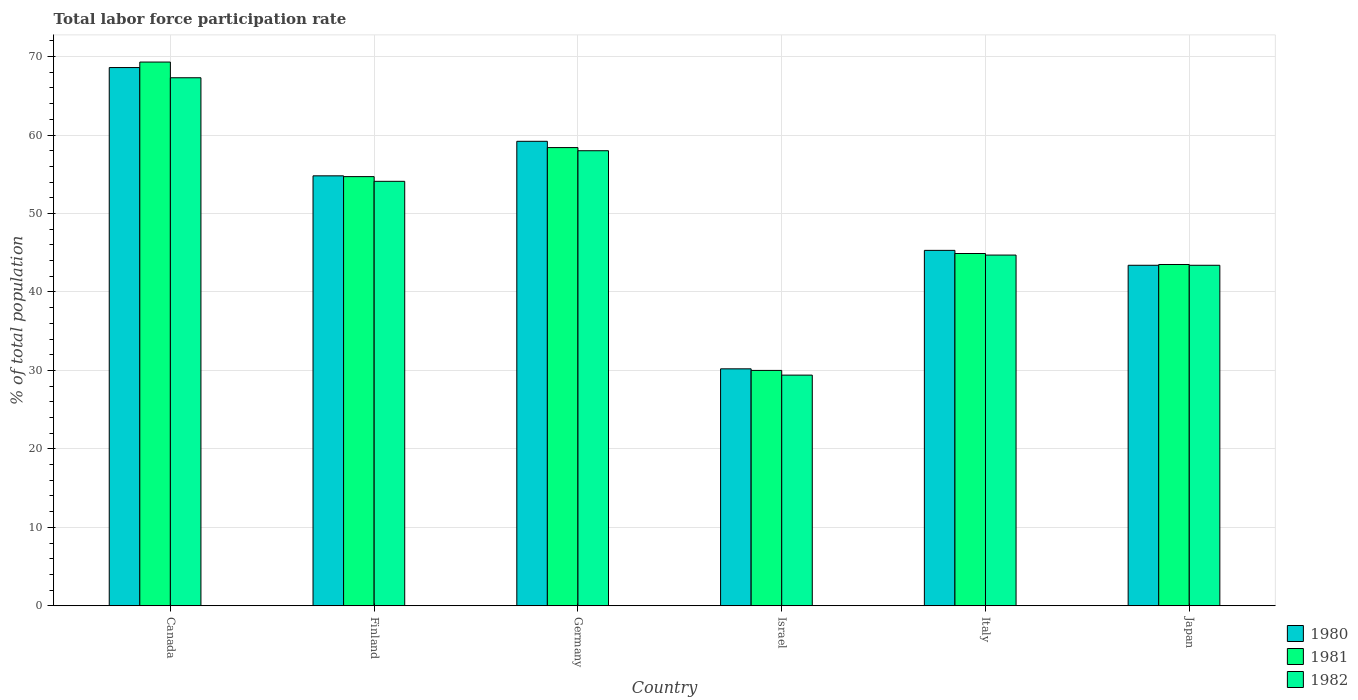How many different coloured bars are there?
Provide a short and direct response. 3. Are the number of bars per tick equal to the number of legend labels?
Keep it short and to the point. Yes. Are the number of bars on each tick of the X-axis equal?
Give a very brief answer. Yes. How many bars are there on the 3rd tick from the left?
Ensure brevity in your answer.  3. How many bars are there on the 1st tick from the right?
Make the answer very short. 3. What is the label of the 2nd group of bars from the left?
Your answer should be very brief. Finland. In how many cases, is the number of bars for a given country not equal to the number of legend labels?
Your response must be concise. 0. What is the total labor force participation rate in 1980 in Germany?
Your answer should be compact. 59.2. Across all countries, what is the maximum total labor force participation rate in 1980?
Offer a terse response. 68.6. Across all countries, what is the minimum total labor force participation rate in 1982?
Keep it short and to the point. 29.4. In which country was the total labor force participation rate in 1981 maximum?
Provide a short and direct response. Canada. In which country was the total labor force participation rate in 1980 minimum?
Your response must be concise. Israel. What is the total total labor force participation rate in 1980 in the graph?
Offer a terse response. 301.5. What is the difference between the total labor force participation rate in 1980 in Israel and that in Japan?
Keep it short and to the point. -13.2. What is the difference between the total labor force participation rate in 1981 in Israel and the total labor force participation rate in 1982 in Germany?
Keep it short and to the point. -28. What is the average total labor force participation rate in 1981 per country?
Your response must be concise. 50.13. What is the difference between the total labor force participation rate of/in 1980 and total labor force participation rate of/in 1981 in Italy?
Give a very brief answer. 0.4. What is the ratio of the total labor force participation rate in 1982 in Germany to that in Japan?
Your answer should be very brief. 1.34. Is the difference between the total labor force participation rate in 1980 in Finland and Japan greater than the difference between the total labor force participation rate in 1981 in Finland and Japan?
Your answer should be compact. Yes. What is the difference between the highest and the second highest total labor force participation rate in 1980?
Ensure brevity in your answer.  -9.4. What is the difference between the highest and the lowest total labor force participation rate in 1980?
Provide a short and direct response. 38.4. In how many countries, is the total labor force participation rate in 1980 greater than the average total labor force participation rate in 1980 taken over all countries?
Make the answer very short. 3. Is the sum of the total labor force participation rate in 1980 in Germany and Japan greater than the maximum total labor force participation rate in 1981 across all countries?
Give a very brief answer. Yes. What does the 1st bar from the right in Israel represents?
Provide a succinct answer. 1982. Is it the case that in every country, the sum of the total labor force participation rate in 1980 and total labor force participation rate in 1982 is greater than the total labor force participation rate in 1981?
Offer a very short reply. Yes. Are all the bars in the graph horizontal?
Your answer should be compact. No. Are the values on the major ticks of Y-axis written in scientific E-notation?
Your answer should be compact. No. Where does the legend appear in the graph?
Provide a succinct answer. Bottom right. How many legend labels are there?
Your response must be concise. 3. What is the title of the graph?
Give a very brief answer. Total labor force participation rate. What is the label or title of the X-axis?
Give a very brief answer. Country. What is the label or title of the Y-axis?
Make the answer very short. % of total population. What is the % of total population in 1980 in Canada?
Offer a very short reply. 68.6. What is the % of total population in 1981 in Canada?
Make the answer very short. 69.3. What is the % of total population in 1982 in Canada?
Keep it short and to the point. 67.3. What is the % of total population in 1980 in Finland?
Ensure brevity in your answer.  54.8. What is the % of total population of 1981 in Finland?
Provide a succinct answer. 54.7. What is the % of total population in 1982 in Finland?
Provide a succinct answer. 54.1. What is the % of total population of 1980 in Germany?
Your response must be concise. 59.2. What is the % of total population in 1981 in Germany?
Offer a very short reply. 58.4. What is the % of total population in 1982 in Germany?
Offer a terse response. 58. What is the % of total population of 1980 in Israel?
Your answer should be compact. 30.2. What is the % of total population in 1981 in Israel?
Ensure brevity in your answer.  30. What is the % of total population in 1982 in Israel?
Offer a terse response. 29.4. What is the % of total population of 1980 in Italy?
Provide a succinct answer. 45.3. What is the % of total population in 1981 in Italy?
Your answer should be compact. 44.9. What is the % of total population in 1982 in Italy?
Keep it short and to the point. 44.7. What is the % of total population of 1980 in Japan?
Offer a very short reply. 43.4. What is the % of total population of 1981 in Japan?
Provide a succinct answer. 43.5. What is the % of total population of 1982 in Japan?
Ensure brevity in your answer.  43.4. Across all countries, what is the maximum % of total population in 1980?
Provide a succinct answer. 68.6. Across all countries, what is the maximum % of total population of 1981?
Your response must be concise. 69.3. Across all countries, what is the maximum % of total population in 1982?
Your answer should be very brief. 67.3. Across all countries, what is the minimum % of total population of 1980?
Provide a short and direct response. 30.2. Across all countries, what is the minimum % of total population of 1982?
Your answer should be compact. 29.4. What is the total % of total population of 1980 in the graph?
Your answer should be very brief. 301.5. What is the total % of total population in 1981 in the graph?
Keep it short and to the point. 300.8. What is the total % of total population in 1982 in the graph?
Your answer should be very brief. 296.9. What is the difference between the % of total population in 1981 in Canada and that in Germany?
Offer a terse response. 10.9. What is the difference between the % of total population in 1980 in Canada and that in Israel?
Your answer should be very brief. 38.4. What is the difference between the % of total population in 1981 in Canada and that in Israel?
Keep it short and to the point. 39.3. What is the difference between the % of total population of 1982 in Canada and that in Israel?
Provide a succinct answer. 37.9. What is the difference between the % of total population of 1980 in Canada and that in Italy?
Make the answer very short. 23.3. What is the difference between the % of total population of 1981 in Canada and that in Italy?
Your response must be concise. 24.4. What is the difference between the % of total population in 1982 in Canada and that in Italy?
Your answer should be compact. 22.6. What is the difference between the % of total population in 1980 in Canada and that in Japan?
Make the answer very short. 25.2. What is the difference between the % of total population of 1981 in Canada and that in Japan?
Keep it short and to the point. 25.8. What is the difference between the % of total population in 1982 in Canada and that in Japan?
Ensure brevity in your answer.  23.9. What is the difference between the % of total population in 1981 in Finland and that in Germany?
Provide a short and direct response. -3.7. What is the difference between the % of total population in 1982 in Finland and that in Germany?
Give a very brief answer. -3.9. What is the difference between the % of total population of 1980 in Finland and that in Israel?
Provide a short and direct response. 24.6. What is the difference between the % of total population in 1981 in Finland and that in Israel?
Offer a terse response. 24.7. What is the difference between the % of total population of 1982 in Finland and that in Israel?
Make the answer very short. 24.7. What is the difference between the % of total population in 1980 in Germany and that in Israel?
Provide a short and direct response. 29. What is the difference between the % of total population of 1981 in Germany and that in Israel?
Your answer should be compact. 28.4. What is the difference between the % of total population of 1982 in Germany and that in Israel?
Keep it short and to the point. 28.6. What is the difference between the % of total population of 1981 in Germany and that in Italy?
Your answer should be very brief. 13.5. What is the difference between the % of total population of 1980 in Germany and that in Japan?
Your answer should be very brief. 15.8. What is the difference between the % of total population of 1980 in Israel and that in Italy?
Offer a very short reply. -15.1. What is the difference between the % of total population of 1981 in Israel and that in Italy?
Your response must be concise. -14.9. What is the difference between the % of total population in 1982 in Israel and that in Italy?
Your response must be concise. -15.3. What is the difference between the % of total population in 1981 in Israel and that in Japan?
Give a very brief answer. -13.5. What is the difference between the % of total population in 1982 in Israel and that in Japan?
Provide a short and direct response. -14. What is the difference between the % of total population in 1980 in Italy and that in Japan?
Ensure brevity in your answer.  1.9. What is the difference between the % of total population in 1980 in Canada and the % of total population in 1982 in Finland?
Offer a terse response. 14.5. What is the difference between the % of total population of 1981 in Canada and the % of total population of 1982 in Finland?
Make the answer very short. 15.2. What is the difference between the % of total population of 1980 in Canada and the % of total population of 1981 in Israel?
Your answer should be compact. 38.6. What is the difference between the % of total population in 1980 in Canada and the % of total population in 1982 in Israel?
Offer a terse response. 39.2. What is the difference between the % of total population of 1981 in Canada and the % of total population of 1982 in Israel?
Offer a very short reply. 39.9. What is the difference between the % of total population in 1980 in Canada and the % of total population in 1981 in Italy?
Keep it short and to the point. 23.7. What is the difference between the % of total population of 1980 in Canada and the % of total population of 1982 in Italy?
Your answer should be compact. 23.9. What is the difference between the % of total population in 1981 in Canada and the % of total population in 1982 in Italy?
Your answer should be very brief. 24.6. What is the difference between the % of total population in 1980 in Canada and the % of total population in 1981 in Japan?
Offer a very short reply. 25.1. What is the difference between the % of total population in 1980 in Canada and the % of total population in 1982 in Japan?
Ensure brevity in your answer.  25.2. What is the difference between the % of total population in 1981 in Canada and the % of total population in 1982 in Japan?
Provide a succinct answer. 25.9. What is the difference between the % of total population in 1980 in Finland and the % of total population in 1981 in Israel?
Make the answer very short. 24.8. What is the difference between the % of total population of 1980 in Finland and the % of total population of 1982 in Israel?
Your response must be concise. 25.4. What is the difference between the % of total population in 1981 in Finland and the % of total population in 1982 in Israel?
Your answer should be very brief. 25.3. What is the difference between the % of total population in 1980 in Finland and the % of total population in 1981 in Italy?
Make the answer very short. 9.9. What is the difference between the % of total population in 1980 in Finland and the % of total population in 1982 in Italy?
Your answer should be very brief. 10.1. What is the difference between the % of total population in 1980 in Finland and the % of total population in 1981 in Japan?
Ensure brevity in your answer.  11.3. What is the difference between the % of total population in 1980 in Germany and the % of total population in 1981 in Israel?
Give a very brief answer. 29.2. What is the difference between the % of total population of 1980 in Germany and the % of total population of 1982 in Israel?
Your answer should be very brief. 29.8. What is the difference between the % of total population of 1981 in Germany and the % of total population of 1982 in Israel?
Your answer should be very brief. 29. What is the difference between the % of total population in 1980 in Germany and the % of total population in 1981 in Italy?
Your answer should be compact. 14.3. What is the difference between the % of total population of 1980 in Germany and the % of total population of 1982 in Japan?
Give a very brief answer. 15.8. What is the difference between the % of total population in 1981 in Germany and the % of total population in 1982 in Japan?
Give a very brief answer. 15. What is the difference between the % of total population of 1980 in Israel and the % of total population of 1981 in Italy?
Your answer should be compact. -14.7. What is the difference between the % of total population of 1981 in Israel and the % of total population of 1982 in Italy?
Provide a succinct answer. -14.7. What is the difference between the % of total population in 1980 in Israel and the % of total population in 1981 in Japan?
Give a very brief answer. -13.3. What is the difference between the % of total population in 1981 in Israel and the % of total population in 1982 in Japan?
Make the answer very short. -13.4. What is the difference between the % of total population in 1980 in Italy and the % of total population in 1981 in Japan?
Keep it short and to the point. 1.8. What is the average % of total population in 1980 per country?
Keep it short and to the point. 50.25. What is the average % of total population in 1981 per country?
Give a very brief answer. 50.13. What is the average % of total population of 1982 per country?
Ensure brevity in your answer.  49.48. What is the difference between the % of total population in 1980 and % of total population in 1982 in Canada?
Provide a short and direct response. 1.3. What is the difference between the % of total population of 1981 and % of total population of 1982 in Canada?
Offer a very short reply. 2. What is the difference between the % of total population in 1980 and % of total population in 1981 in Finland?
Give a very brief answer. 0.1. What is the difference between the % of total population in 1980 and % of total population in 1982 in Finland?
Provide a short and direct response. 0.7. What is the difference between the % of total population of 1981 and % of total population of 1982 in Germany?
Your response must be concise. 0.4. What is the difference between the % of total population in 1980 and % of total population in 1981 in Israel?
Your response must be concise. 0.2. What is the difference between the % of total population in 1980 and % of total population in 1982 in Israel?
Provide a short and direct response. 0.8. What is the difference between the % of total population of 1981 and % of total population of 1982 in Israel?
Offer a very short reply. 0.6. What is the difference between the % of total population of 1980 and % of total population of 1982 in Italy?
Your answer should be compact. 0.6. What is the difference between the % of total population in 1980 and % of total population in 1981 in Japan?
Provide a succinct answer. -0.1. What is the ratio of the % of total population of 1980 in Canada to that in Finland?
Your response must be concise. 1.25. What is the ratio of the % of total population in 1981 in Canada to that in Finland?
Provide a short and direct response. 1.27. What is the ratio of the % of total population in 1982 in Canada to that in Finland?
Your response must be concise. 1.24. What is the ratio of the % of total population of 1980 in Canada to that in Germany?
Provide a succinct answer. 1.16. What is the ratio of the % of total population of 1981 in Canada to that in Germany?
Offer a terse response. 1.19. What is the ratio of the % of total population in 1982 in Canada to that in Germany?
Provide a short and direct response. 1.16. What is the ratio of the % of total population in 1980 in Canada to that in Israel?
Provide a short and direct response. 2.27. What is the ratio of the % of total population in 1981 in Canada to that in Israel?
Keep it short and to the point. 2.31. What is the ratio of the % of total population of 1982 in Canada to that in Israel?
Offer a very short reply. 2.29. What is the ratio of the % of total population of 1980 in Canada to that in Italy?
Provide a short and direct response. 1.51. What is the ratio of the % of total population of 1981 in Canada to that in Italy?
Offer a terse response. 1.54. What is the ratio of the % of total population of 1982 in Canada to that in Italy?
Offer a very short reply. 1.51. What is the ratio of the % of total population of 1980 in Canada to that in Japan?
Your response must be concise. 1.58. What is the ratio of the % of total population in 1981 in Canada to that in Japan?
Offer a very short reply. 1.59. What is the ratio of the % of total population in 1982 in Canada to that in Japan?
Give a very brief answer. 1.55. What is the ratio of the % of total population in 1980 in Finland to that in Germany?
Offer a very short reply. 0.93. What is the ratio of the % of total population in 1981 in Finland to that in Germany?
Provide a short and direct response. 0.94. What is the ratio of the % of total population in 1982 in Finland to that in Germany?
Ensure brevity in your answer.  0.93. What is the ratio of the % of total population of 1980 in Finland to that in Israel?
Give a very brief answer. 1.81. What is the ratio of the % of total population of 1981 in Finland to that in Israel?
Offer a very short reply. 1.82. What is the ratio of the % of total population in 1982 in Finland to that in Israel?
Provide a short and direct response. 1.84. What is the ratio of the % of total population in 1980 in Finland to that in Italy?
Give a very brief answer. 1.21. What is the ratio of the % of total population in 1981 in Finland to that in Italy?
Provide a succinct answer. 1.22. What is the ratio of the % of total population in 1982 in Finland to that in Italy?
Provide a succinct answer. 1.21. What is the ratio of the % of total population of 1980 in Finland to that in Japan?
Make the answer very short. 1.26. What is the ratio of the % of total population of 1981 in Finland to that in Japan?
Provide a succinct answer. 1.26. What is the ratio of the % of total population of 1982 in Finland to that in Japan?
Offer a terse response. 1.25. What is the ratio of the % of total population in 1980 in Germany to that in Israel?
Give a very brief answer. 1.96. What is the ratio of the % of total population in 1981 in Germany to that in Israel?
Offer a very short reply. 1.95. What is the ratio of the % of total population in 1982 in Germany to that in Israel?
Offer a very short reply. 1.97. What is the ratio of the % of total population of 1980 in Germany to that in Italy?
Keep it short and to the point. 1.31. What is the ratio of the % of total population of 1981 in Germany to that in Italy?
Provide a short and direct response. 1.3. What is the ratio of the % of total population of 1982 in Germany to that in Italy?
Your response must be concise. 1.3. What is the ratio of the % of total population of 1980 in Germany to that in Japan?
Offer a very short reply. 1.36. What is the ratio of the % of total population of 1981 in Germany to that in Japan?
Give a very brief answer. 1.34. What is the ratio of the % of total population of 1982 in Germany to that in Japan?
Provide a short and direct response. 1.34. What is the ratio of the % of total population of 1981 in Israel to that in Italy?
Your response must be concise. 0.67. What is the ratio of the % of total population of 1982 in Israel to that in Italy?
Your response must be concise. 0.66. What is the ratio of the % of total population of 1980 in Israel to that in Japan?
Keep it short and to the point. 0.7. What is the ratio of the % of total population in 1981 in Israel to that in Japan?
Offer a terse response. 0.69. What is the ratio of the % of total population of 1982 in Israel to that in Japan?
Keep it short and to the point. 0.68. What is the ratio of the % of total population in 1980 in Italy to that in Japan?
Offer a very short reply. 1.04. What is the ratio of the % of total population in 1981 in Italy to that in Japan?
Make the answer very short. 1.03. What is the difference between the highest and the second highest % of total population of 1980?
Your answer should be compact. 9.4. What is the difference between the highest and the second highest % of total population of 1982?
Your response must be concise. 9.3. What is the difference between the highest and the lowest % of total population in 1980?
Keep it short and to the point. 38.4. What is the difference between the highest and the lowest % of total population of 1981?
Your answer should be very brief. 39.3. What is the difference between the highest and the lowest % of total population in 1982?
Provide a succinct answer. 37.9. 